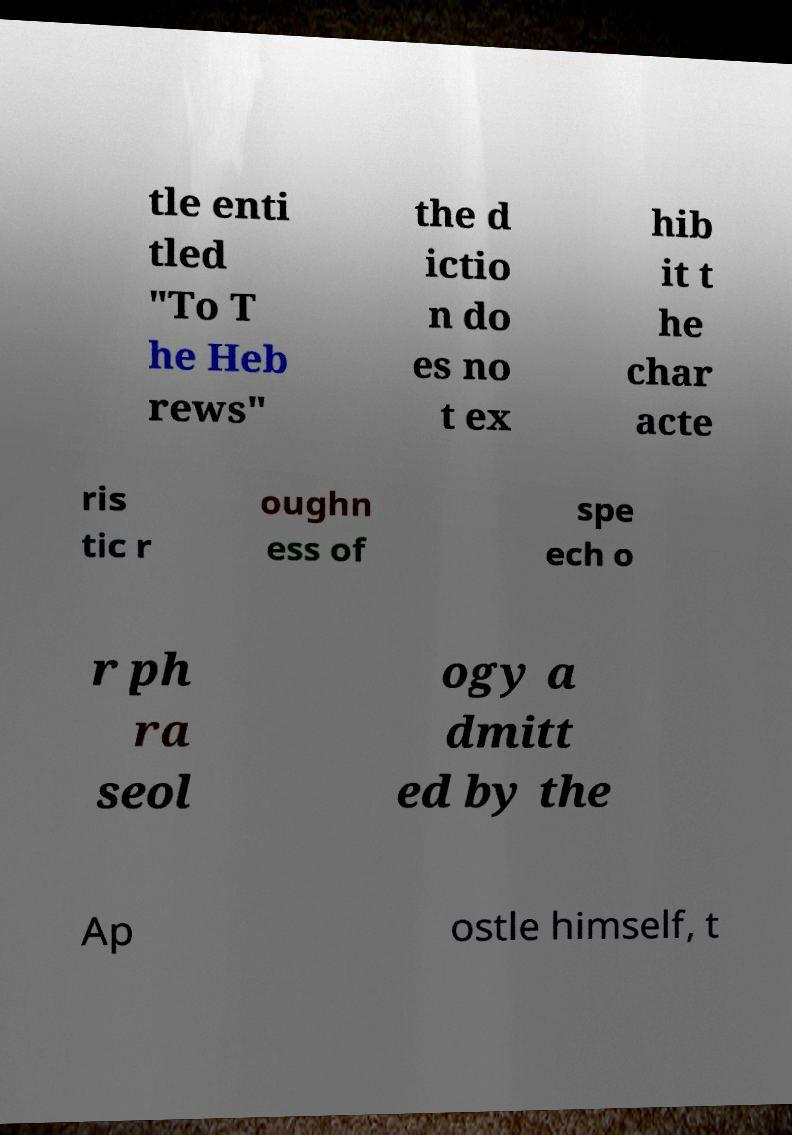What messages or text are displayed in this image? I need them in a readable, typed format. tle enti tled "To T he Heb rews" the d ictio n do es no t ex hib it t he char acte ris tic r oughn ess of spe ech o r ph ra seol ogy a dmitt ed by the Ap ostle himself, t 